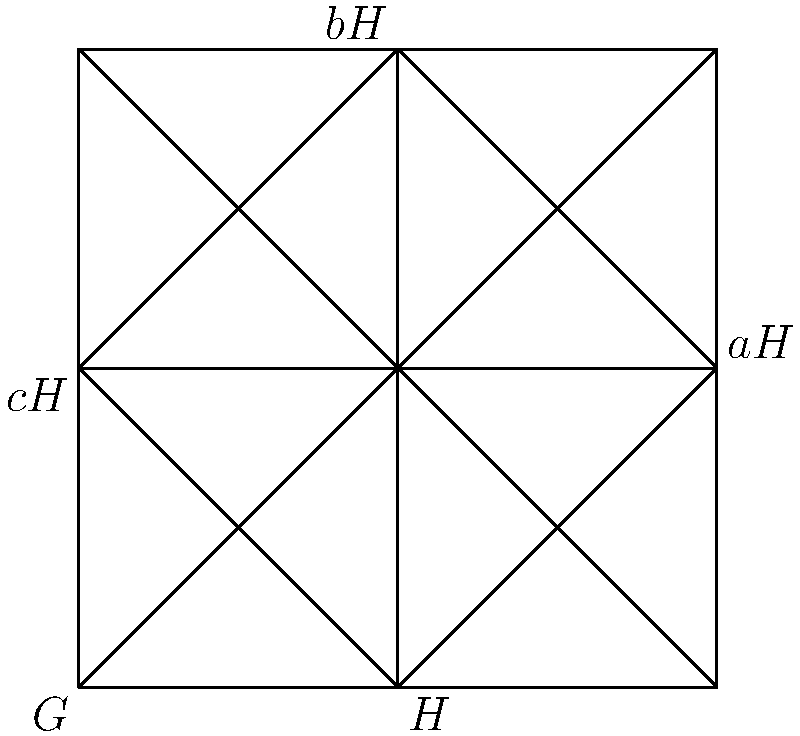In the lattice diagram representing the cosets of a normal subgroup $H$ in group $G$, how many distinct left cosets of $H$ are shown, and what principle of group theory does this illustrate? To answer this question, let's analyze the lattice diagram step-by-step:

1. The outer square represents the entire group $G$.
2. The inner square represents the normal subgroup $H$.
3. The other regions in the diagram represent the left cosets of $H$ in $G$.

Now, let's count the distinct left cosets:

1. We see $H$ itself, which is always a coset (the identity coset).
2. We see three other regions labeled $aH$, $bH$, and $cH$.

Therefore, we can count 4 distinct left cosets in total.

This illustration demonstrates an important principle in group theory:

The cosets of a normal subgroup partition the group into disjoint subsets of equal size. This is known as Lagrange's Theorem, which states that the order of a subgroup $H$ of a finite group $G$ divides the order of $G$.

In this case, we see that $G$ is divided into 4 equal parts, each representing a coset. This means that the index of $H$ in $G$ (the number of cosets) is 4, and the order of $H$ is 1/4 of the order of $G$.

This concept is particularly relevant to the Mormon faith, as it relates to the idea of organization and divine order, which are important principles in LDS theology. Just as the cosets create a structured partition of the group, the LDS Church emphasizes a divinely ordained structure and organization in both earthly and heavenly realms.
Answer: 4 distinct left cosets; Lagrange's Theorem 